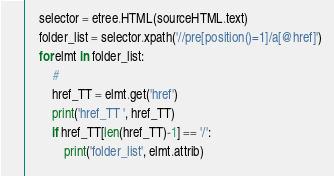Convert code to text. <code><loc_0><loc_0><loc_500><loc_500><_Python_>    selector = etree.HTML(sourceHTML.text)
    folder_list = selector.xpath('//pre[position()=1]/a[@href]')
    for elmt in folder_list:
        #
        href_TT = elmt.get('href')
        print('href_TT ', href_TT)
        if href_TT[len(href_TT)-1] == '/':
            print('folder_list', elmt.attrib)</code> 